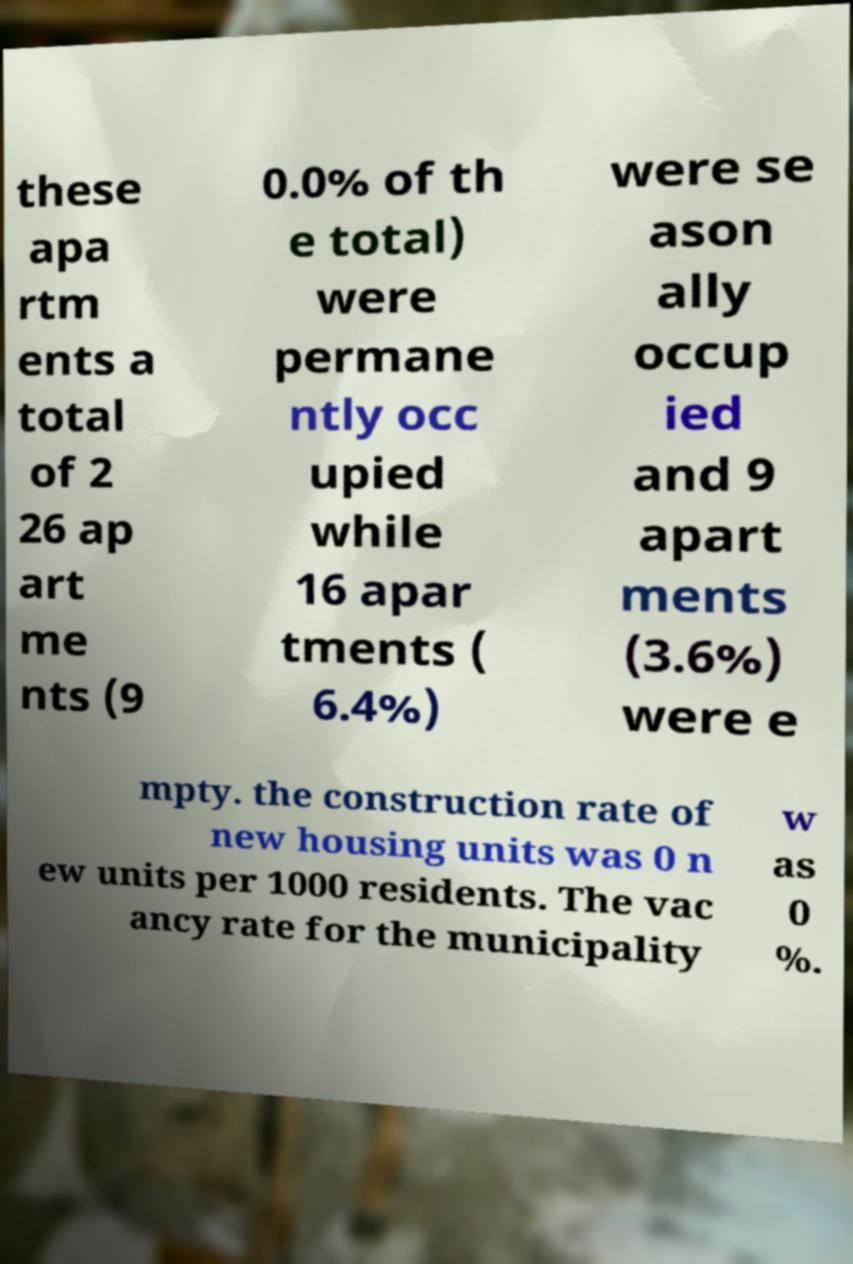Please identify and transcribe the text found in this image. these apa rtm ents a total of 2 26 ap art me nts (9 0.0% of th e total) were permane ntly occ upied while 16 apar tments ( 6.4%) were se ason ally occup ied and 9 apart ments (3.6%) were e mpty. the construction rate of new housing units was 0 n ew units per 1000 residents. The vac ancy rate for the municipality w as 0 %. 